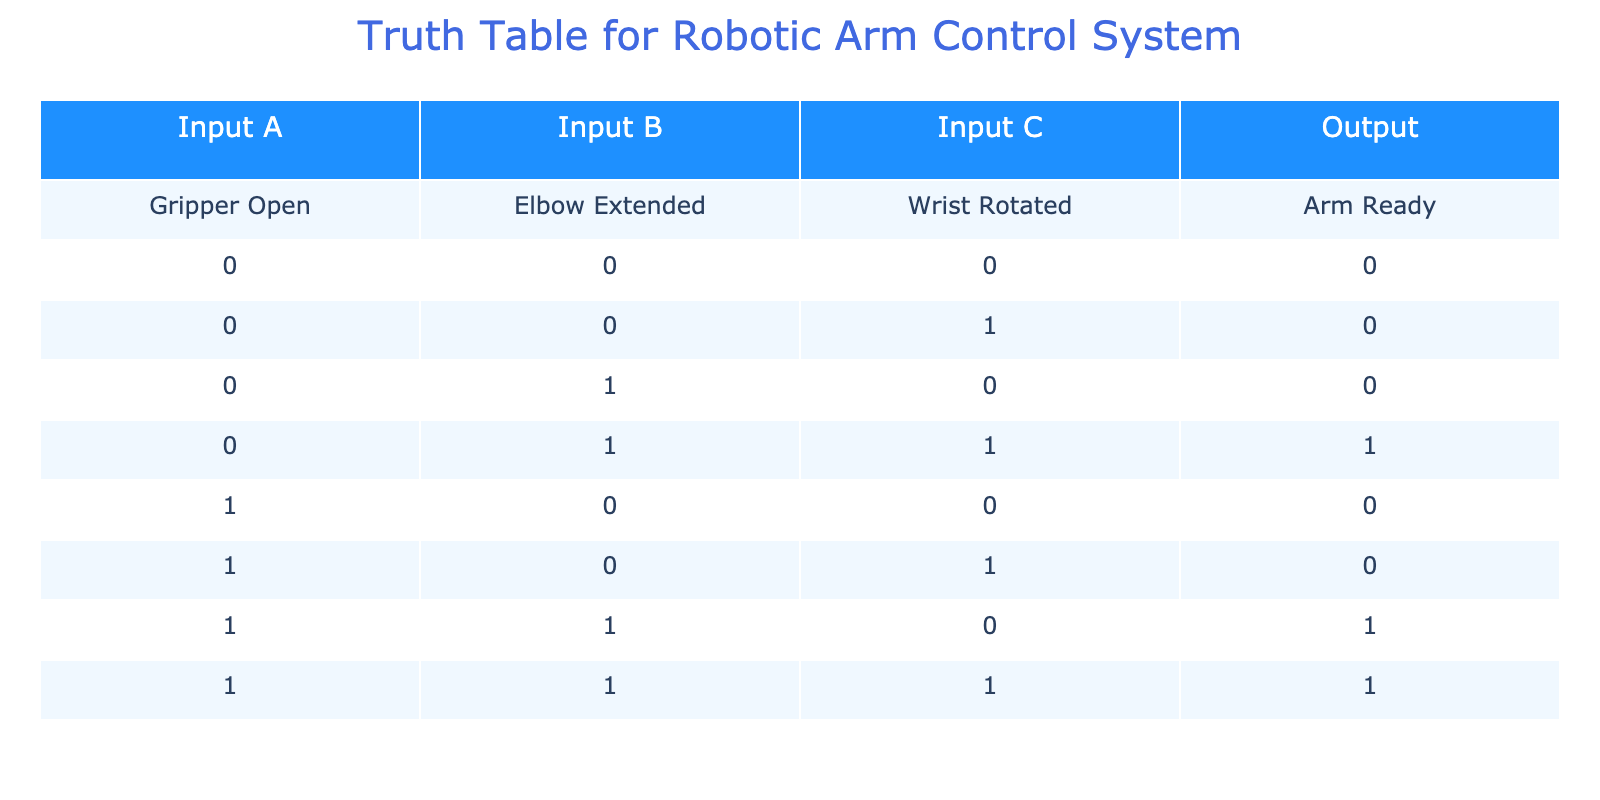What is the output when all inputs are set to zero? Looking at the row where Input A, Input B, and Input C are all 0, the corresponding Output is also 0.
Answer: 0 How many combinations result in the arm being ready? Scanning through the Output column, we find that the Output is 1 in three instances: the combinations of (0, 1, 1), (1, 1, 0), and (1, 1, 1). Therefore, there are three combinations.
Answer: 3 Is the arm ready when the Gripper is open and the Elbow is extended? We check for the combination where Input A is 1 and Input B is 1. Here, the Output is 1, indicating that the arm is indeed ready.
Answer: Yes What is the total number of input combinations that result in a not ready arm? We can count the combinations that result in an Output of 0. There are five combinations where the Output is 0.
Answer: 5 When the Gripper is open and the Wrist is not rotated, what is the arm's state? Looking at the row with Input A as 1 and Input C as 0, the Output is 0. Therefore, the arm is not ready.
Answer: Not ready What two conditions must be satisfied for the arm to be ready? Checking the rows where Output is 1 reveals that the conditions for readiness typically include combinations of the Elbow being extended (Input B = 1) along with any state of Input C, or when both the Elbow and Wrist are rotated (Input B = 1 and Input C = 1). Thus, the conditions are the Elbow extended and/or the Wrist rotated.
Answer: Elbow extended, Wrist rotated How many input combinations lead to both the Elbow extended and the arm being ready? Reviewing the rows, the combinations of (0, 1, 1), (1, 1, 0), and (1, 1, 1) all have the Elbow extended and are also ready. That's a total of three combinations.
Answer: 3 If the Gripper is open and the Wrist is rotated, what is required for the arm to be ready? In the data, when Input A is 1 and Input C is 1, we need to check Input B. There are two conditions, both require that Input B needs to be 1 for the arm to be ready.
Answer: Input B must be 1 What is the relationship between Input C and the arm's readiness? By examining the table, whenever Input C is 0, the Output is 0 unless Input B is 1. Hence, for the arm to be ready with Input C being 0, Input B must also be 1.
Answer: Input B must be 1 when C is 0 